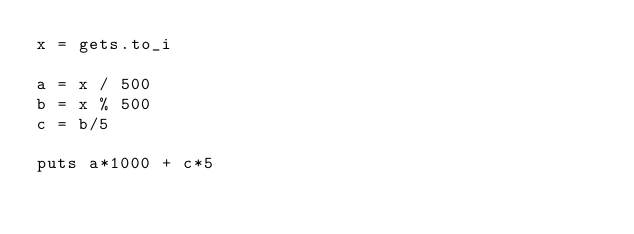<code> <loc_0><loc_0><loc_500><loc_500><_Ruby_>x = gets.to_i

a = x / 500
b = x % 500
c = b/5

puts a*1000 + c*5</code> 